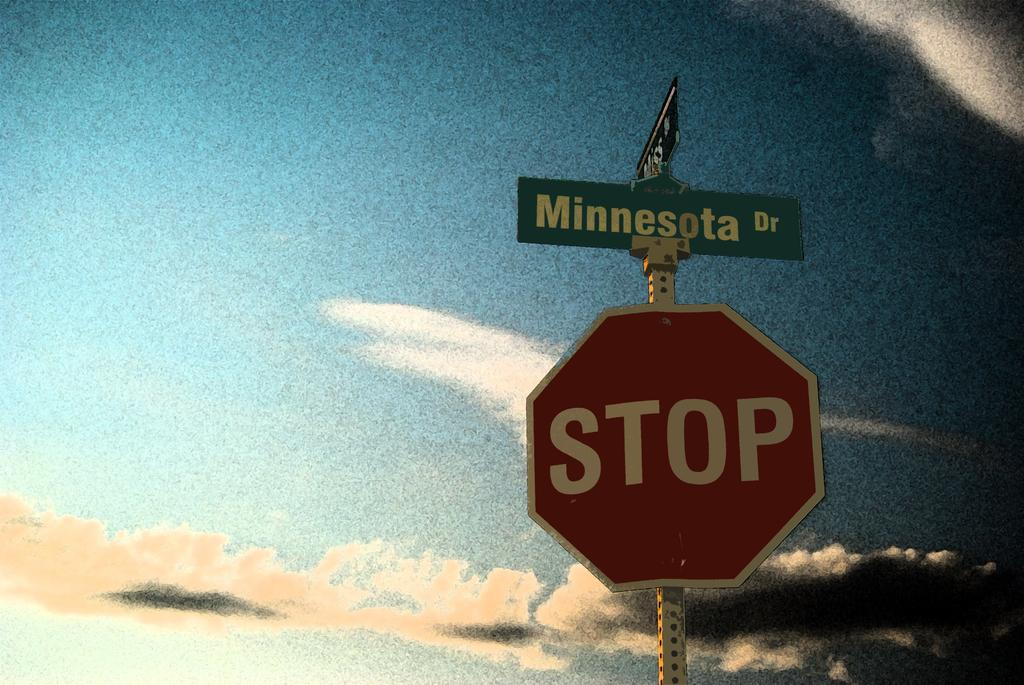<image>
Provide a brief description of the given image. A stop sign below the street sign of Minnesota Dr. 